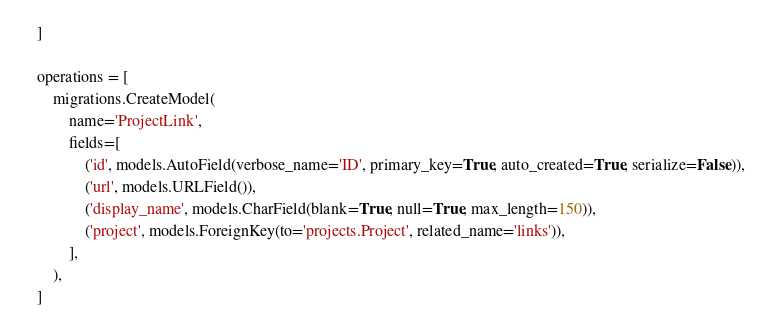<code> <loc_0><loc_0><loc_500><loc_500><_Python_>    ]

    operations = [
        migrations.CreateModel(
            name='ProjectLink',
            fields=[
                ('id', models.AutoField(verbose_name='ID', primary_key=True, auto_created=True, serialize=False)),
                ('url', models.URLField()),
                ('display_name', models.CharField(blank=True, null=True, max_length=150)),
                ('project', models.ForeignKey(to='projects.Project', related_name='links')),
            ],
        ),
    ]
</code> 